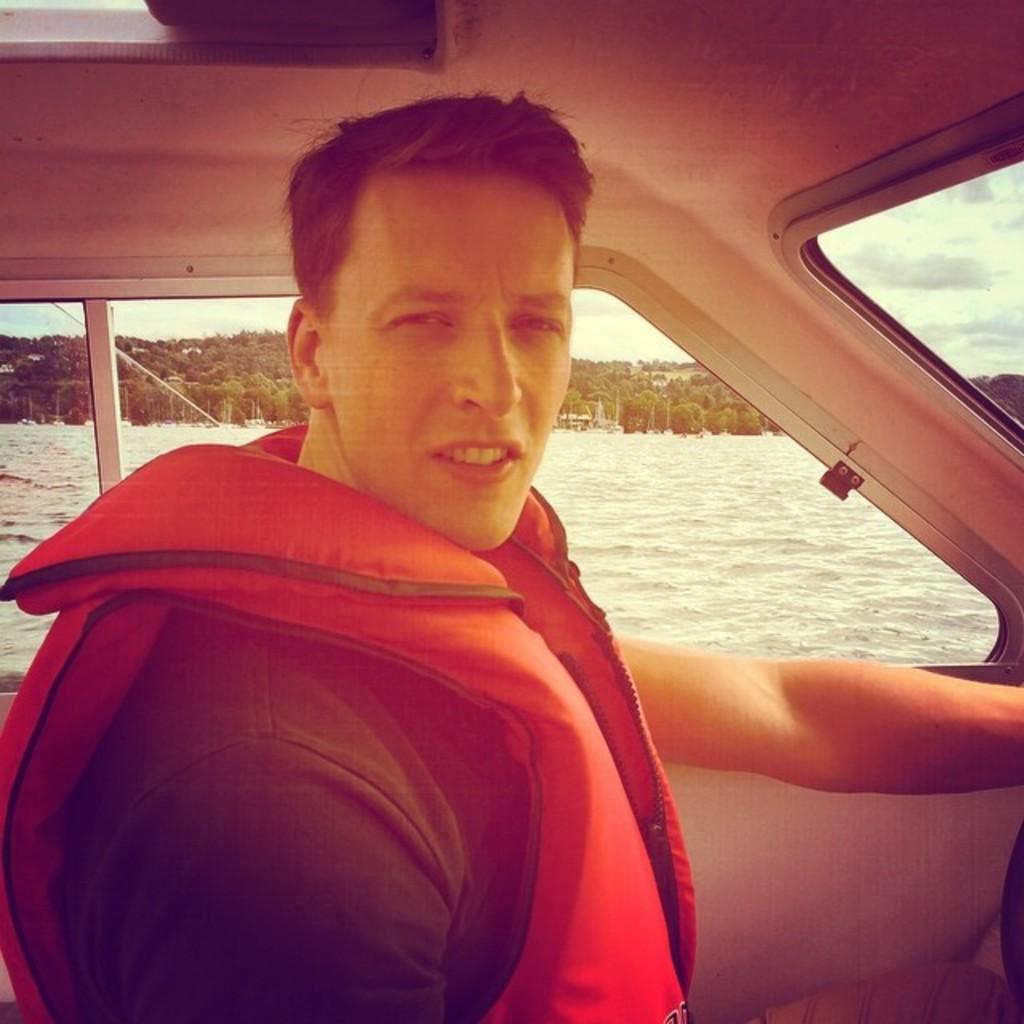What is present inside the vehicle in the image? There is a person in the vehicle. What can be seen in the background of the image? There are trees and poles in the background of the image. How would you describe the sky in the image? The sky is cloudy in the image. How many oranges are hanging from the poles in the image? There are no oranges present in the image; only trees and poles can be seen in the background. What part of the vehicle is the person operating in the image? The provided facts do not specify which part of the vehicle the person is operating, so it cannot be determined from the image. 